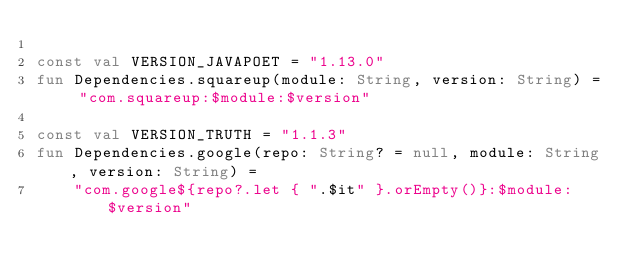Convert code to text. <code><loc_0><loc_0><loc_500><loc_500><_Kotlin_>
const val VERSION_JAVAPOET = "1.13.0"
fun Dependencies.squareup(module: String, version: String) = "com.squareup:$module:$version"

const val VERSION_TRUTH = "1.1.3"
fun Dependencies.google(repo: String? = null, module: String, version: String) =
    "com.google${repo?.let { ".$it" }.orEmpty()}:$module:$version"</code> 